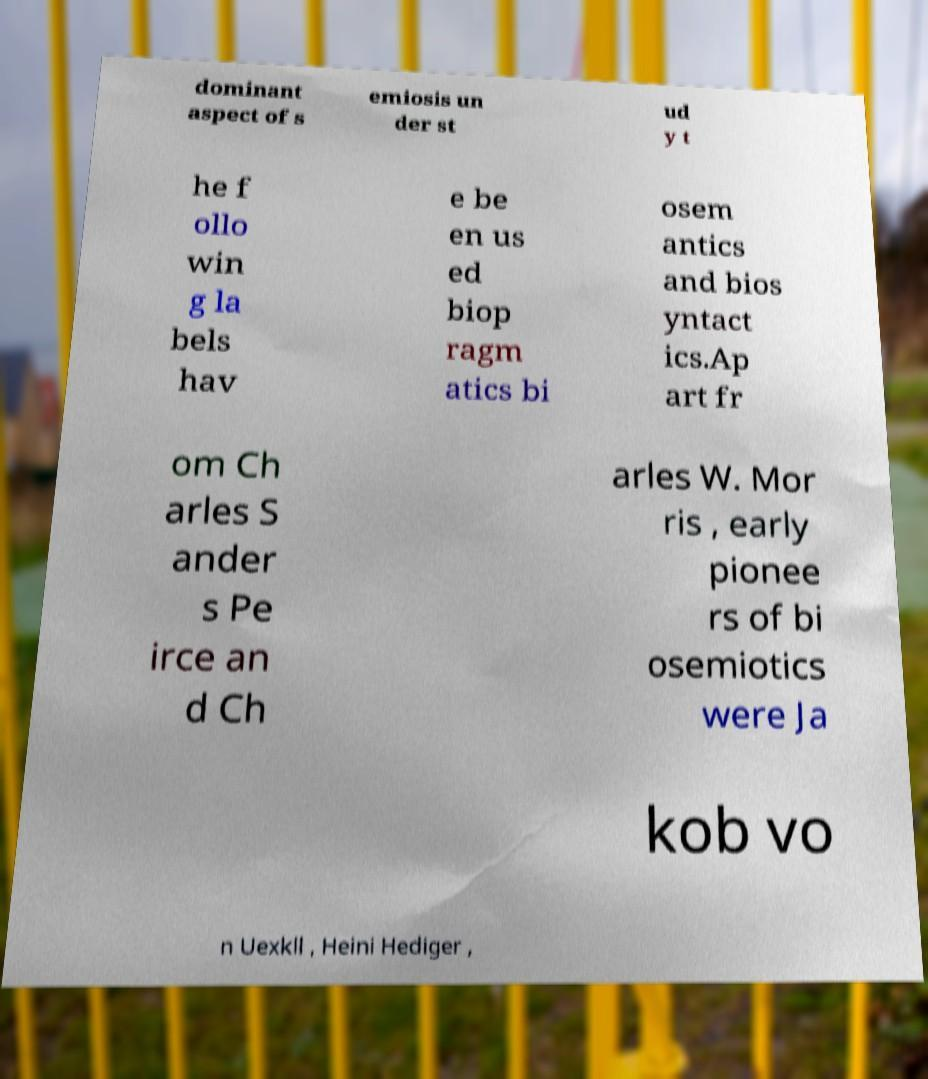Could you assist in decoding the text presented in this image and type it out clearly? dominant aspect of s emiosis un der st ud y t he f ollo win g la bels hav e be en us ed biop ragm atics bi osem antics and bios yntact ics.Ap art fr om Ch arles S ander s Pe irce an d Ch arles W. Mor ris , early pionee rs of bi osemiotics were Ja kob vo n Uexkll , Heini Hediger , 